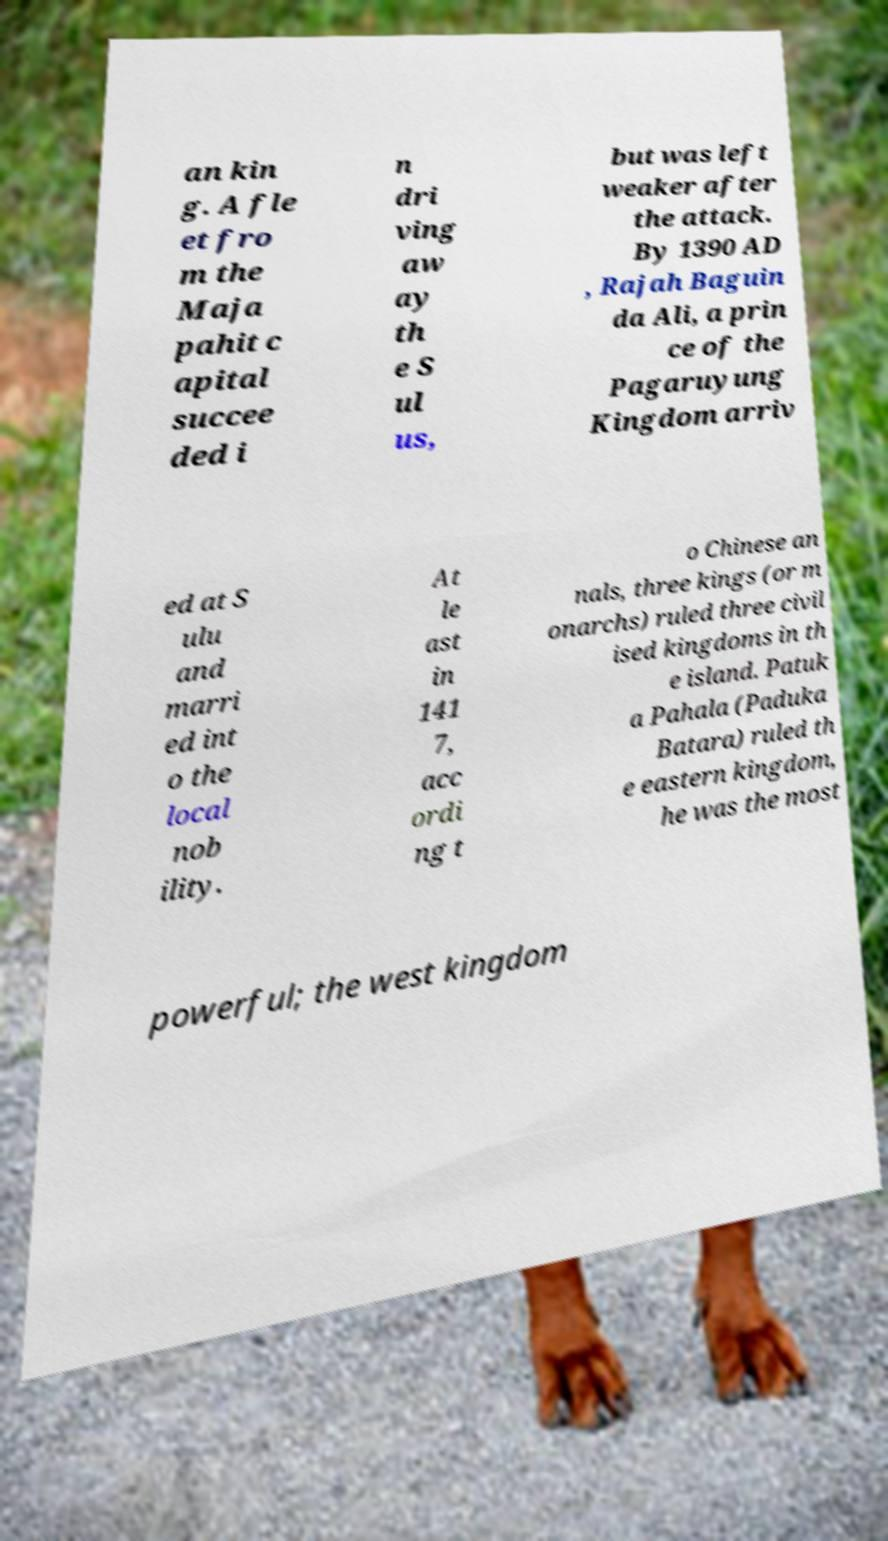I need the written content from this picture converted into text. Can you do that? an kin g. A fle et fro m the Maja pahit c apital succee ded i n dri ving aw ay th e S ul us, but was left weaker after the attack. By 1390 AD , Rajah Baguin da Ali, a prin ce of the Pagaruyung Kingdom arriv ed at S ulu and marri ed int o the local nob ility. At le ast in 141 7, acc ordi ng t o Chinese an nals, three kings (or m onarchs) ruled three civil ised kingdoms in th e island. Patuk a Pahala (Paduka Batara) ruled th e eastern kingdom, he was the most powerful; the west kingdom 